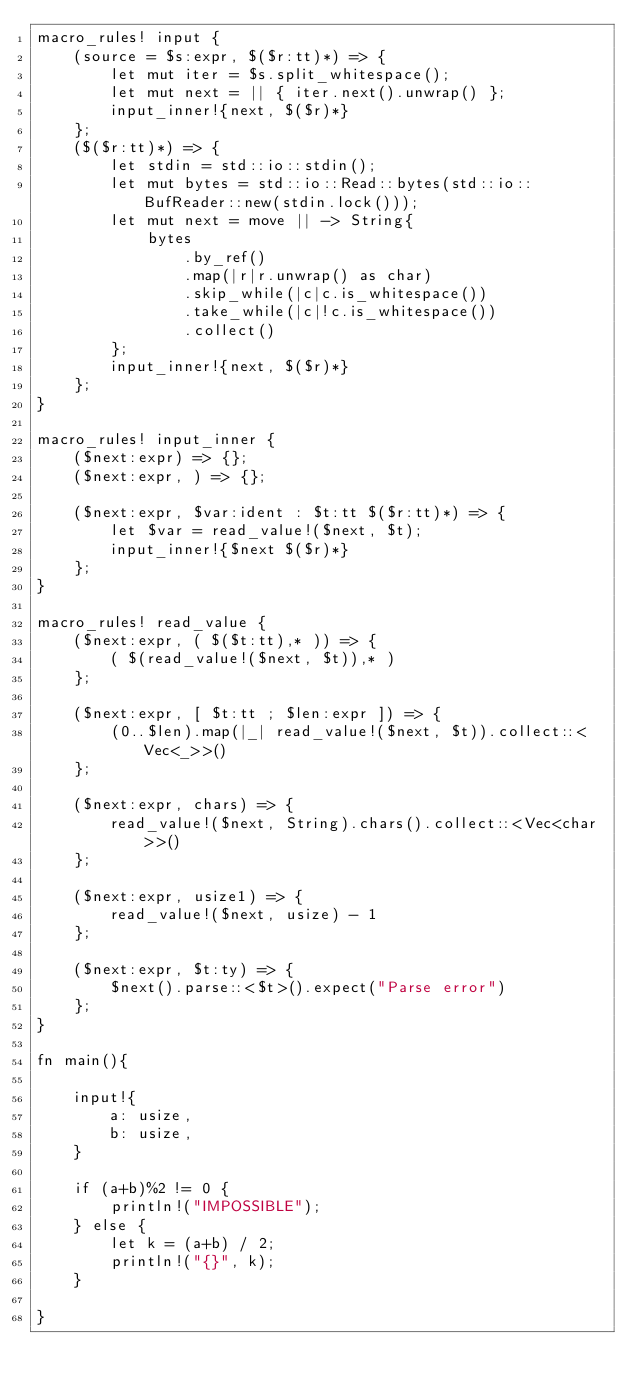<code> <loc_0><loc_0><loc_500><loc_500><_Rust_>macro_rules! input {
    (source = $s:expr, $($r:tt)*) => {
        let mut iter = $s.split_whitespace();
        let mut next = || { iter.next().unwrap() };
        input_inner!{next, $($r)*}
    };
    ($($r:tt)*) => {
        let stdin = std::io::stdin();
        let mut bytes = std::io::Read::bytes(std::io::BufReader::new(stdin.lock()));
        let mut next = move || -> String{
            bytes
                .by_ref()
                .map(|r|r.unwrap() as char)
                .skip_while(|c|c.is_whitespace())
                .take_while(|c|!c.is_whitespace())
                .collect()
        };
        input_inner!{next, $($r)*}
    };
}

macro_rules! input_inner {
    ($next:expr) => {};
    ($next:expr, ) => {};

    ($next:expr, $var:ident : $t:tt $($r:tt)*) => {
        let $var = read_value!($next, $t);
        input_inner!{$next $($r)*}
    };
}

macro_rules! read_value {
    ($next:expr, ( $($t:tt),* )) => {
        ( $(read_value!($next, $t)),* )
    };

    ($next:expr, [ $t:tt ; $len:expr ]) => {
        (0..$len).map(|_| read_value!($next, $t)).collect::<Vec<_>>()
    };

    ($next:expr, chars) => {
        read_value!($next, String).chars().collect::<Vec<char>>()
    };

    ($next:expr, usize1) => {
        read_value!($next, usize) - 1
    };

    ($next:expr, $t:ty) => {
        $next().parse::<$t>().expect("Parse error")
    };
}

fn main(){

    input!{
        a: usize,
        b: usize,
    }

    if (a+b)%2 != 0 {
        println!("IMPOSSIBLE");
    } else {
        let k = (a+b) / 2;
        println!("{}", k);
    }
    
}</code> 